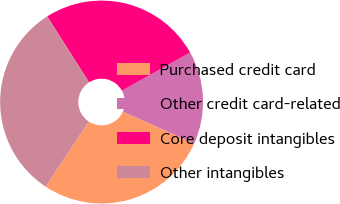Convert chart to OTSL. <chart><loc_0><loc_0><loc_500><loc_500><pie_chart><fcel>Purchased credit card<fcel>Other credit card-related<fcel>Core deposit intangibles<fcel>Other intangibles<nl><fcel>27.58%<fcel>14.83%<fcel>25.9%<fcel>31.69%<nl></chart> 